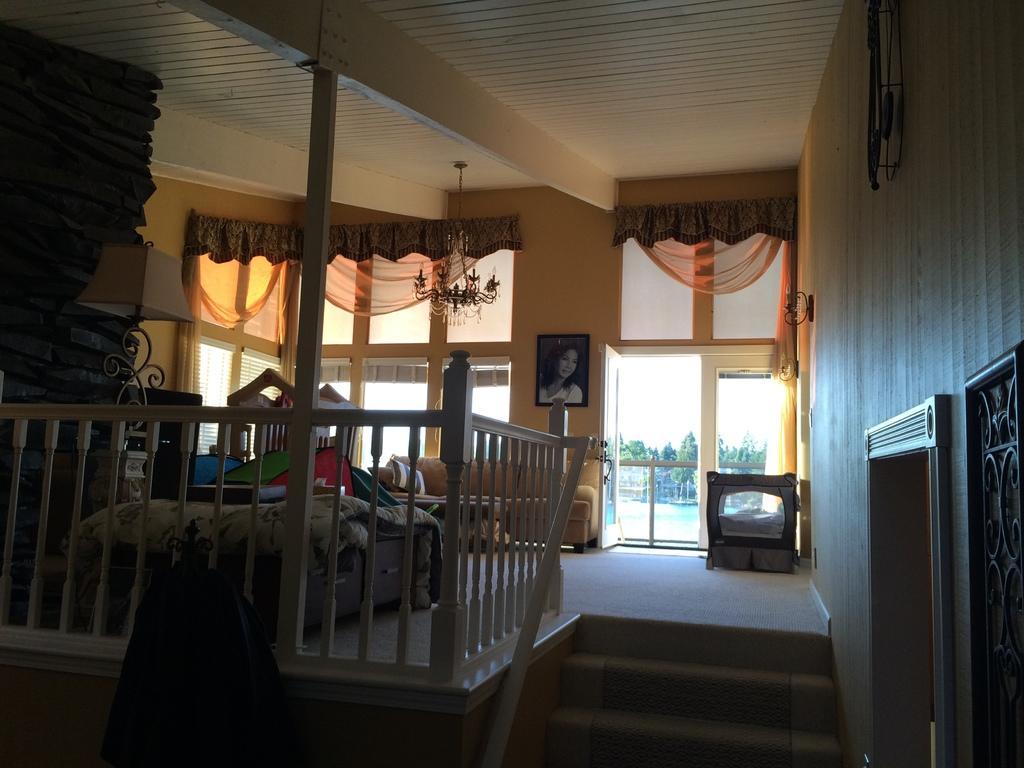In one or two sentences, can you explain what this image depicts? In this picture there is a view of the room. In the front there is a sofa and bed. On the front bottom side we can see the white color steps railing. In the background we can see the Hanging photograph on the wall and big glass door and windows. On the top ceiling there is a hanging chandelier. On the right corner wooden wall and some steps. 